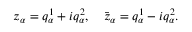Convert formula to latex. <formula><loc_0><loc_0><loc_500><loc_500>z _ { \alpha } = q _ { \alpha } ^ { 1 } + i q _ { \alpha } ^ { 2 } , \quad \bar { z } _ { \alpha } = q _ { \alpha } ^ { 1 } - i q _ { \alpha } ^ { 2 } .</formula> 